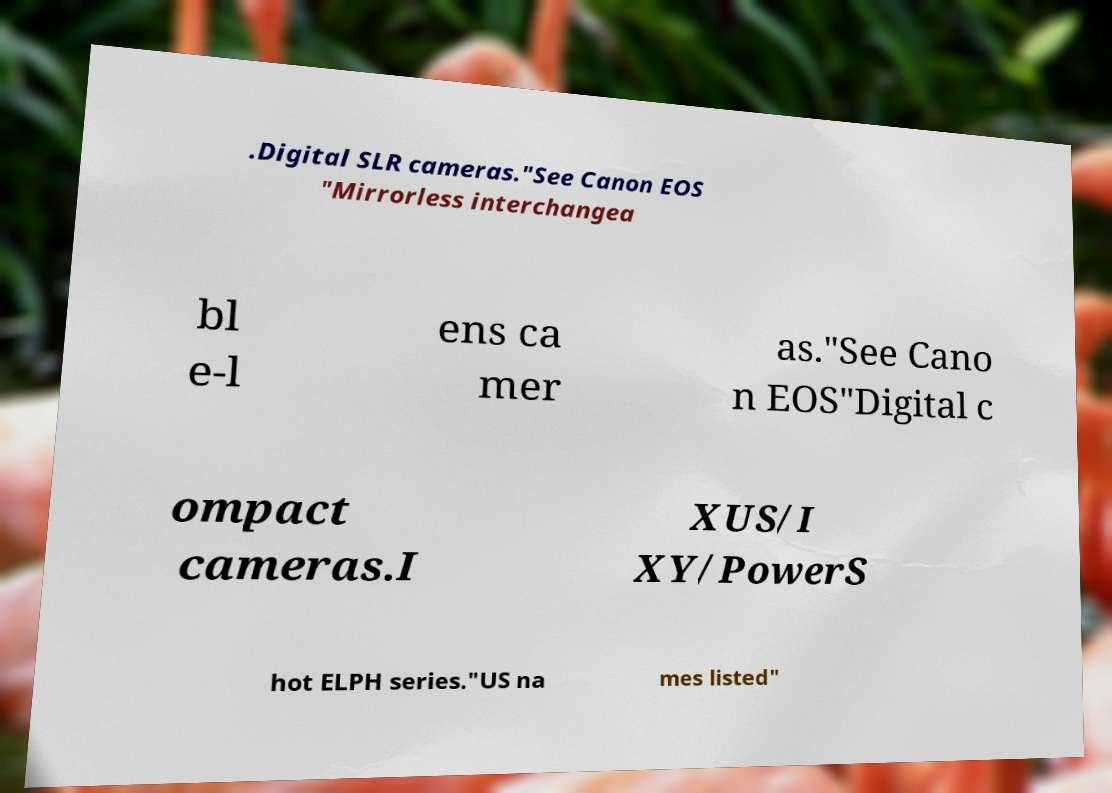Could you assist in decoding the text presented in this image and type it out clearly? .Digital SLR cameras."See Canon EOS "Mirrorless interchangea bl e-l ens ca mer as."See Cano n EOS"Digital c ompact cameras.I XUS/I XY/PowerS hot ELPH series."US na mes listed" 